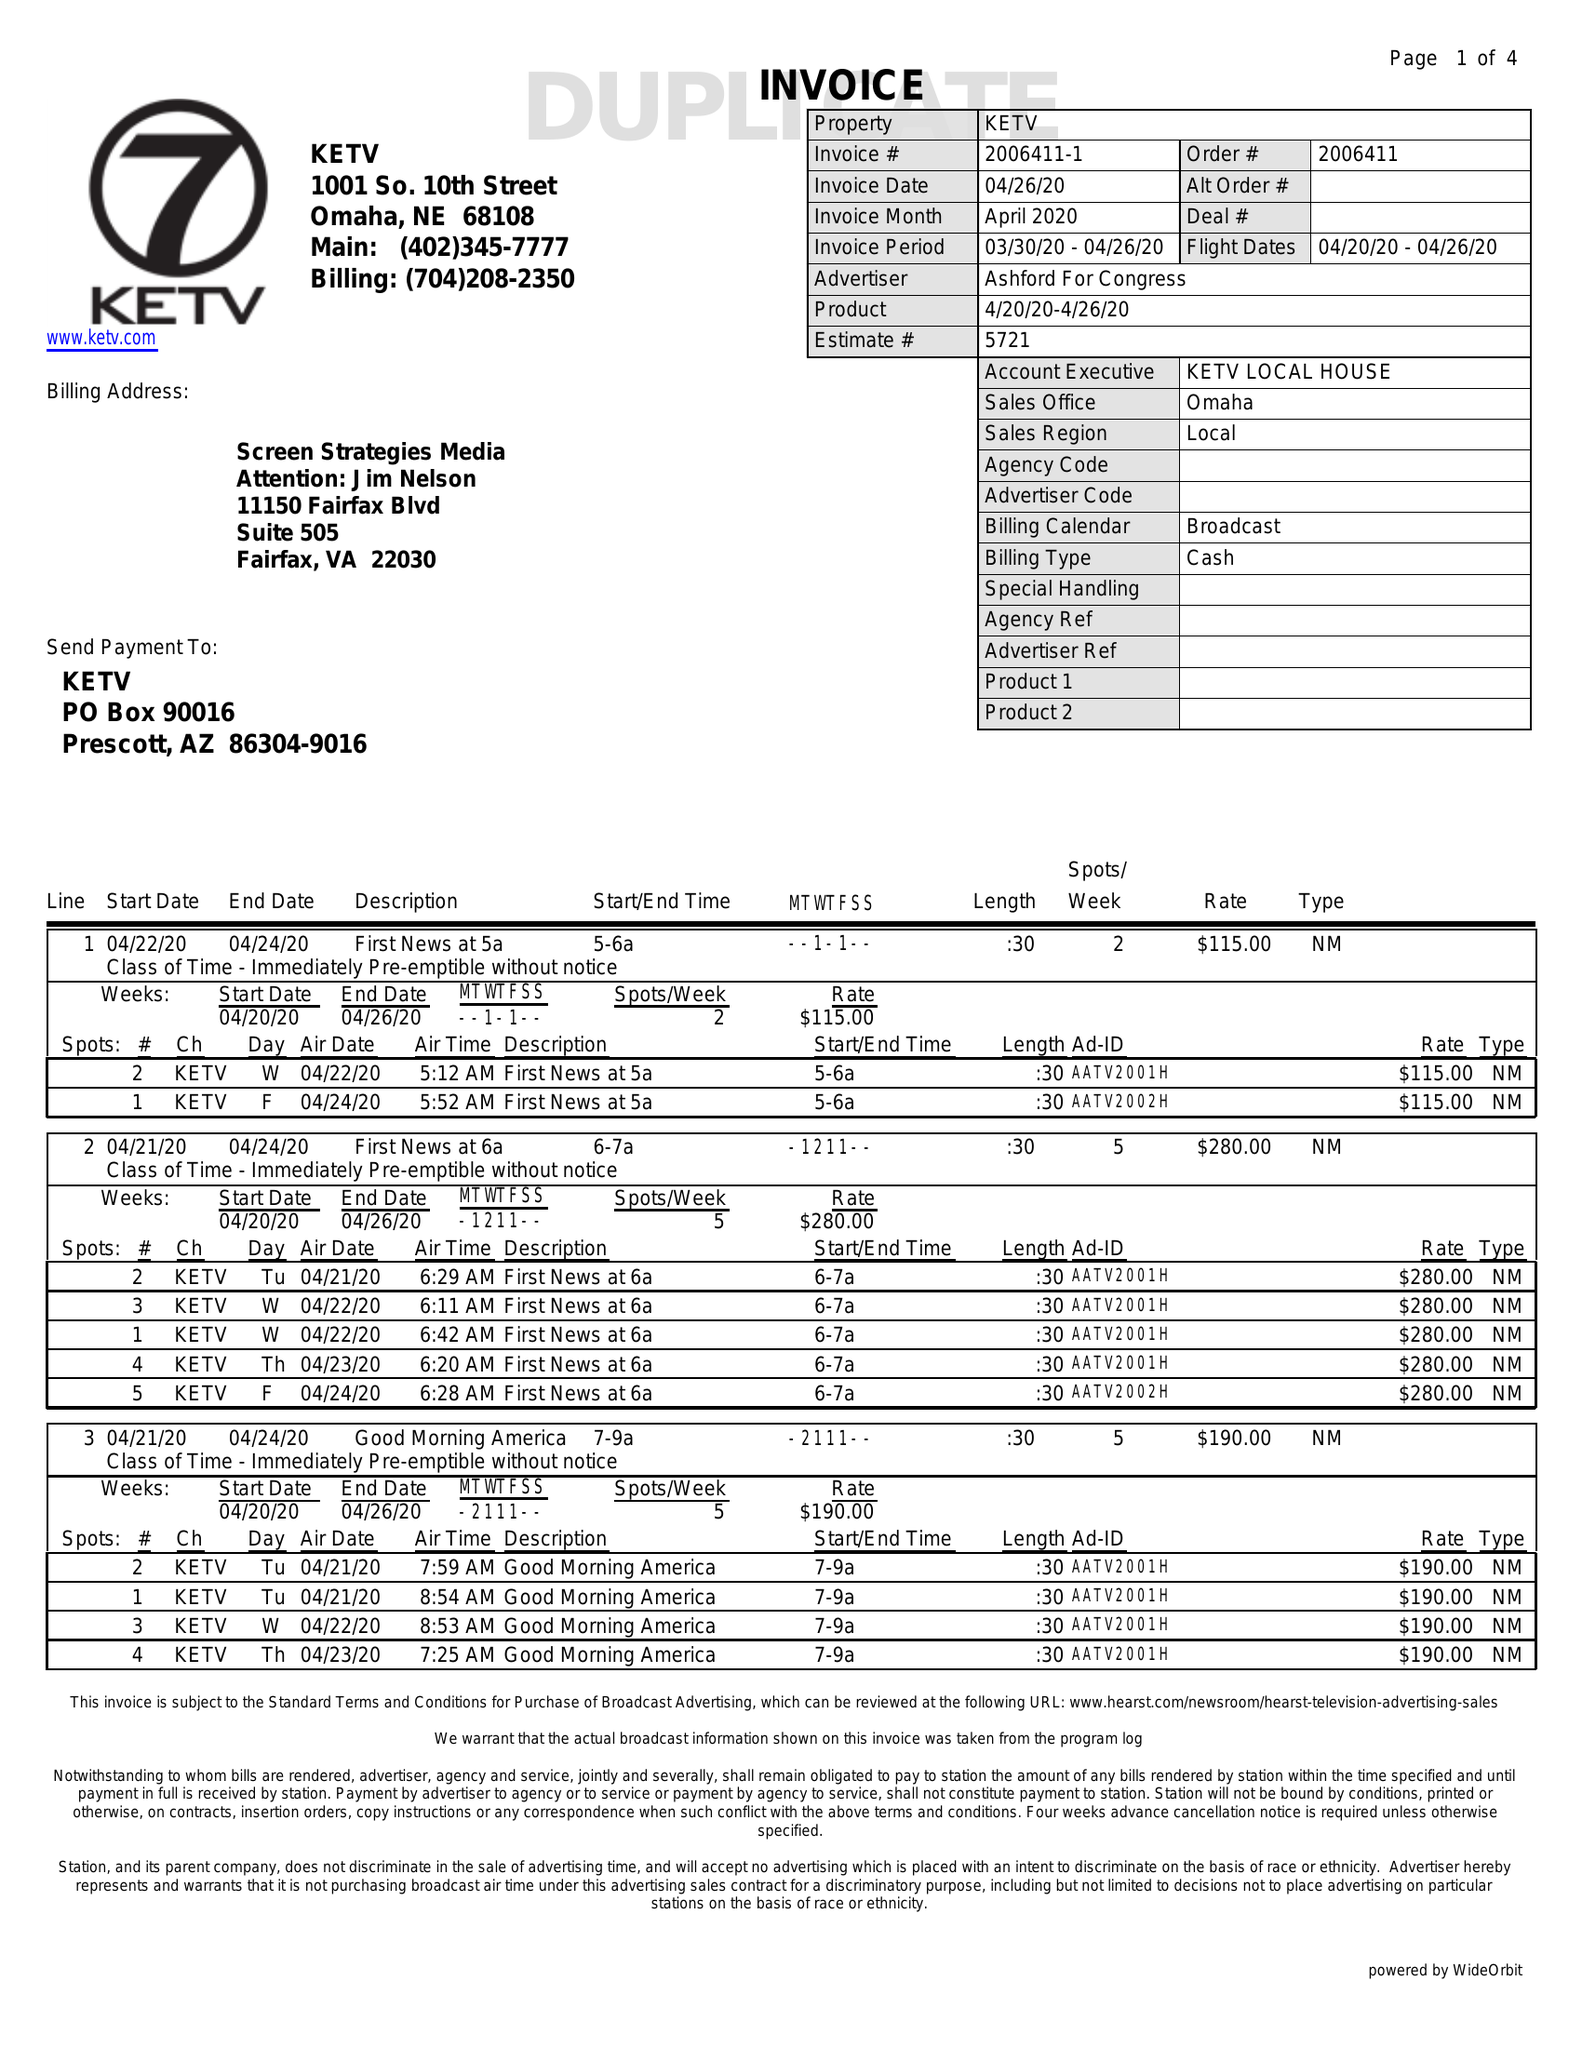What is the value for the contract_num?
Answer the question using a single word or phrase. 2006411 